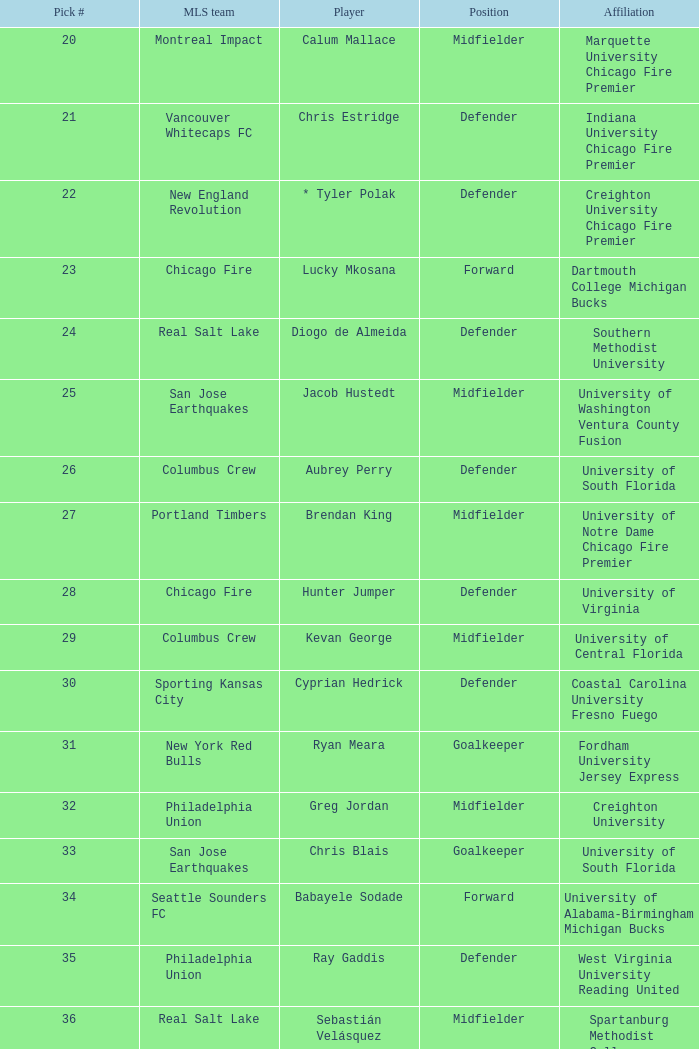At which position did real salt lake pick? 24.0. 